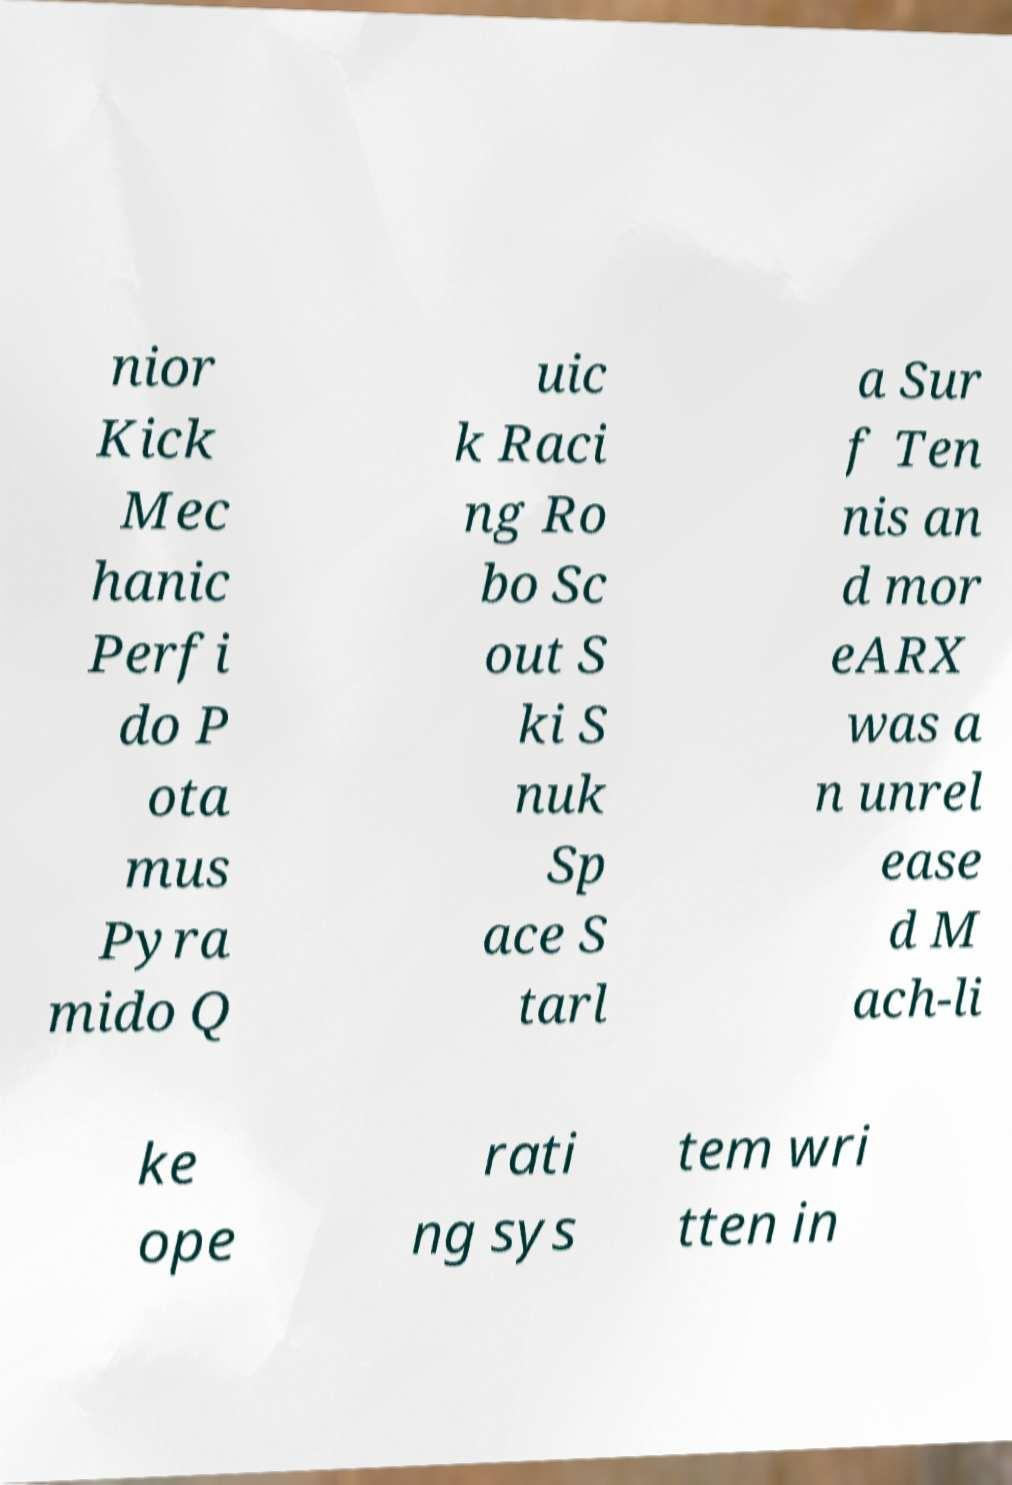Can you read and provide the text displayed in the image?This photo seems to have some interesting text. Can you extract and type it out for me? nior Kick Mec hanic Perfi do P ota mus Pyra mido Q uic k Raci ng Ro bo Sc out S ki S nuk Sp ace S tarl a Sur f Ten nis an d mor eARX was a n unrel ease d M ach-li ke ope rati ng sys tem wri tten in 